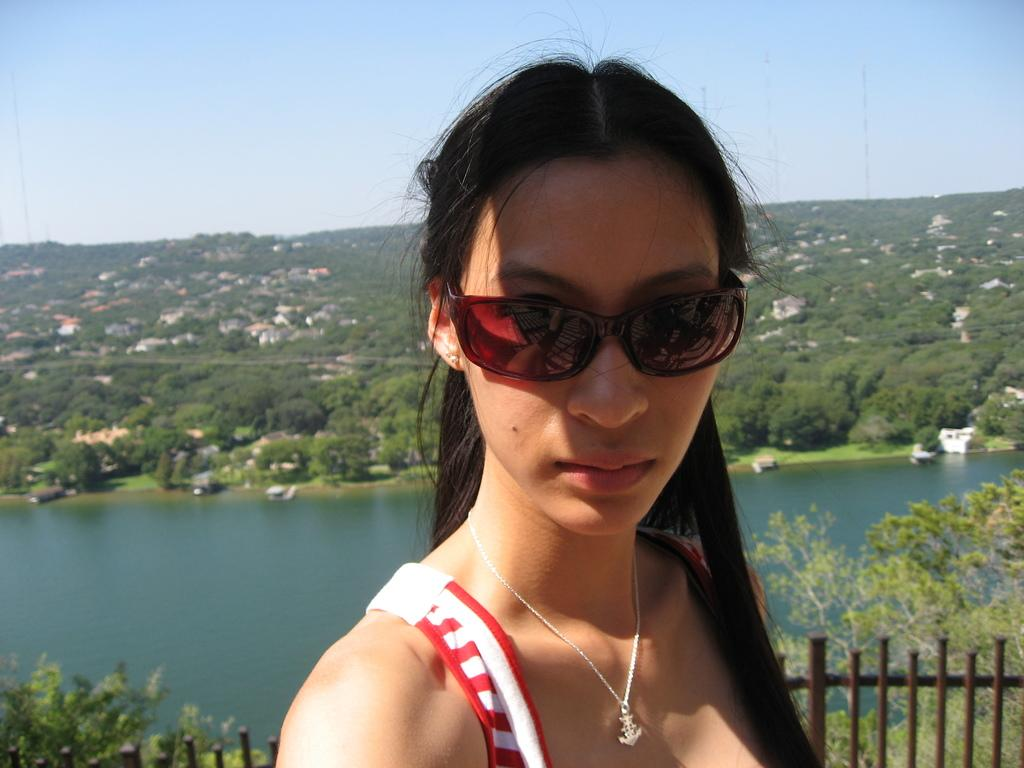Who is present in the image? There is a woman in the image. What can be seen in the foreground of the image? There is fencing in the image. What is visible in the background of the image? There are plants, trees, and buildings in the background of the image. What type of plantation can be seen in the image? There is no plantation present in the image. What is the woman carrying in the image? The provided facts do not mention any bags or items being carried by the woman. 